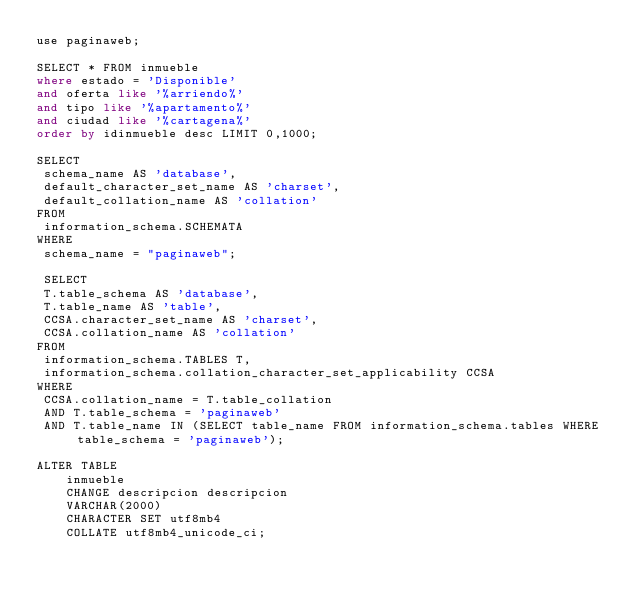Convert code to text. <code><loc_0><loc_0><loc_500><loc_500><_SQL_>use paginaweb;

SELECT * FROM inmueble 
where estado = 'Disponible' 
and oferta like '%arriendo%' 
and tipo like '%apartamento%'
and ciudad like '%cartagena%' 
order by idinmueble desc LIMIT 0,1000;

SELECT
 schema_name AS 'database', 
 default_character_set_name AS 'charset',
 default_collation_name AS 'collation'
FROM
 information_schema.SCHEMATA
WHERE
 schema_name = "paginaweb";
 
 SELECT 
 T.table_schema AS 'database',
 T.table_name AS 'table',
 CCSA.character_set_name AS 'charset',
 CCSA.collation_name AS 'collation'
FROM
 information_schema.TABLES T,
 information_schema.collation_character_set_applicability CCSA
WHERE 
 CCSA.collation_name = T.table_collation
 AND T.table_schema = 'paginaweb'
 AND T.table_name IN (SELECT table_name FROM information_schema.tables WHERE table_schema = 'paginaweb');
 
ALTER TABLE
    inmueble
    CHANGE descripcion descripcion
    VARCHAR(2000)
    CHARACTER SET utf8mb4
    COLLATE utf8mb4_unicode_ci;
</code> 